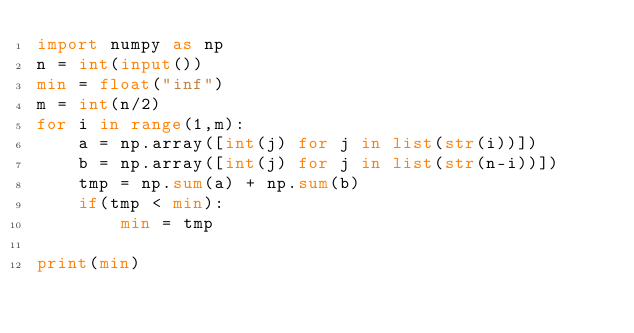<code> <loc_0><loc_0><loc_500><loc_500><_Python_>import numpy as np
n = int(input())
min = float("inf")
m = int(n/2)
for i in range(1,m):
    a = np.array([int(j) for j in list(str(i))])
    b = np.array([int(j) for j in list(str(n-i))])
    tmp = np.sum(a) + np.sum(b)
    if(tmp < min):
        min = tmp

print(min)</code> 